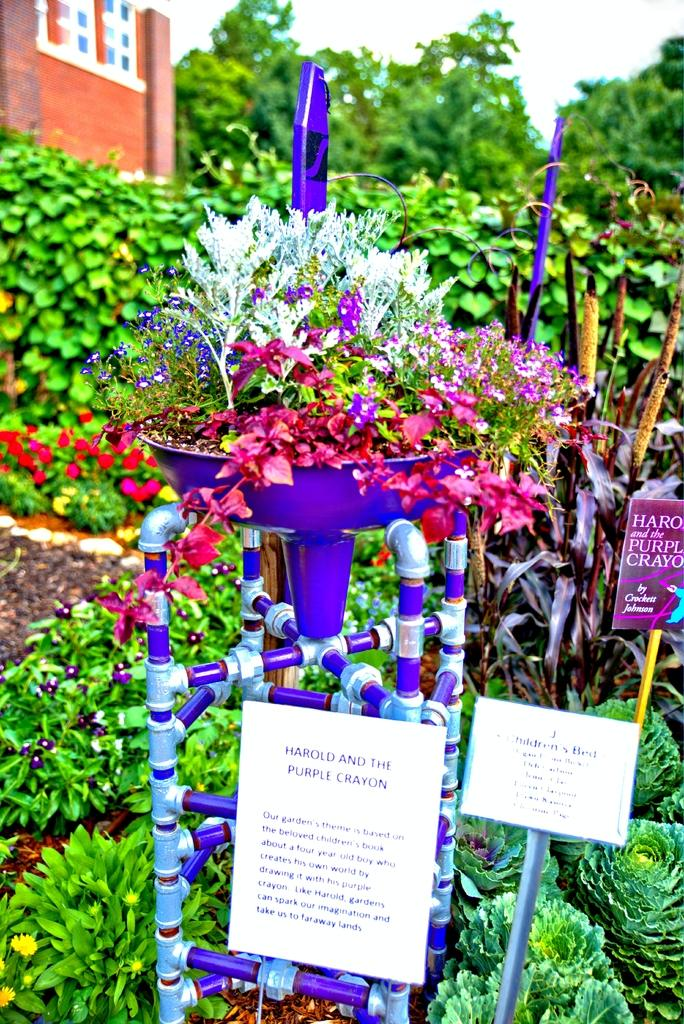What type of vegetation is present in the image? There are flowers, plants, and trees in the image. What type of structure can be seen in the image? There is a building in the image. What else is present in the image besides the vegetation and the building? There are papers in the image. How many kittens are playing on the edge of the building in the image? There are no kittens present in the image, and therefore no such activity can be observed. 